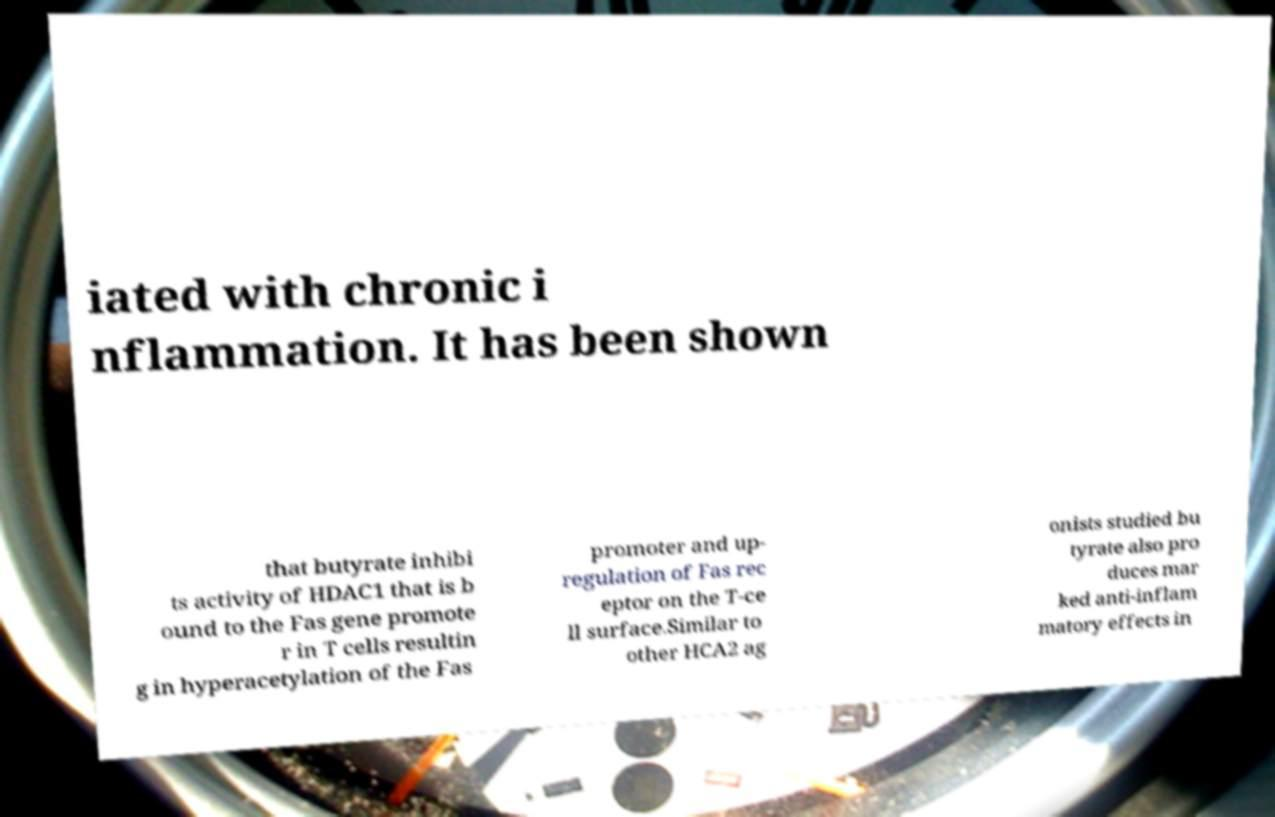Could you extract and type out the text from this image? iated with chronic i nflammation. It has been shown that butyrate inhibi ts activity of HDAC1 that is b ound to the Fas gene promote r in T cells resultin g in hyperacetylation of the Fas promoter and up- regulation of Fas rec eptor on the T-ce ll surface.Similar to other HCA2 ag onists studied bu tyrate also pro duces mar ked anti-inflam matory effects in 